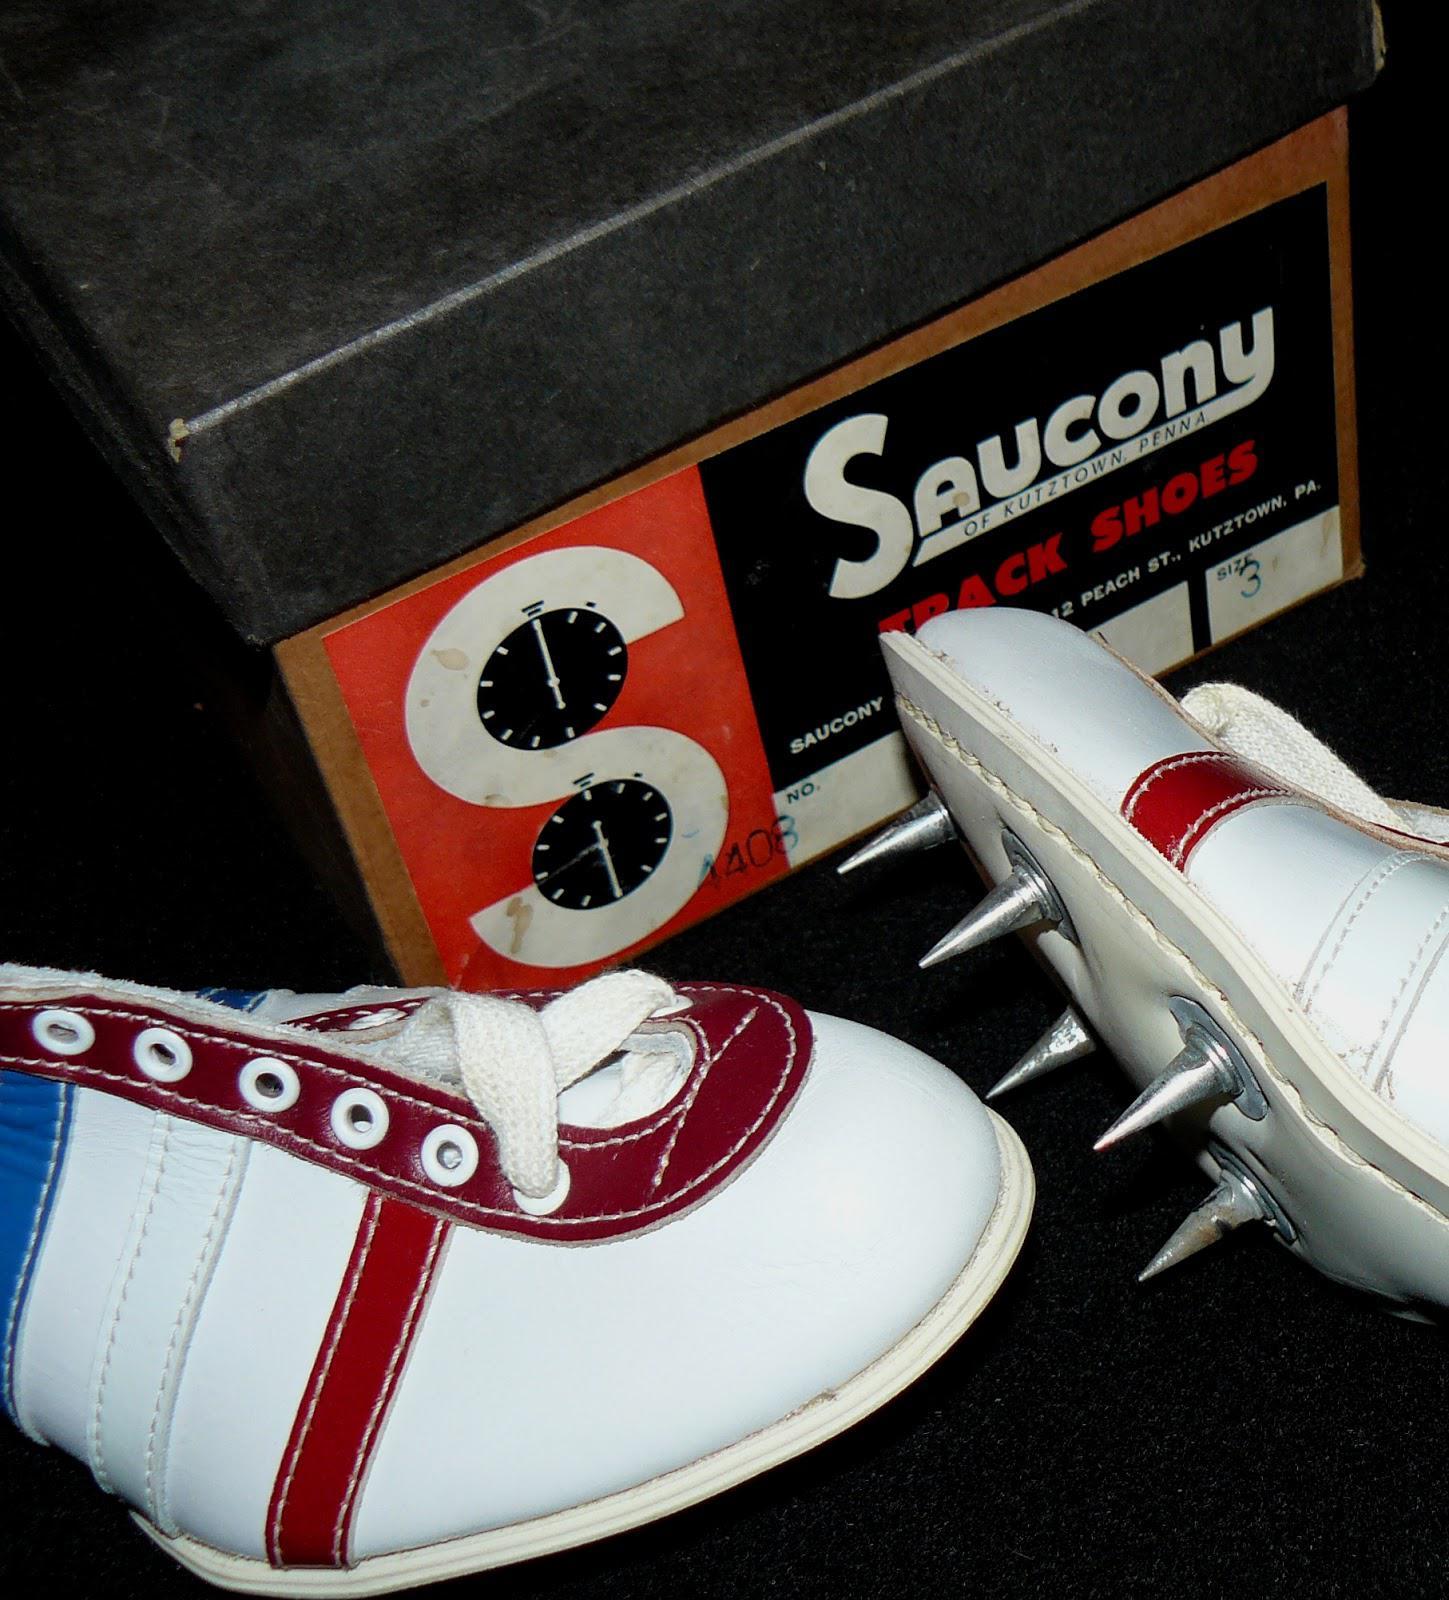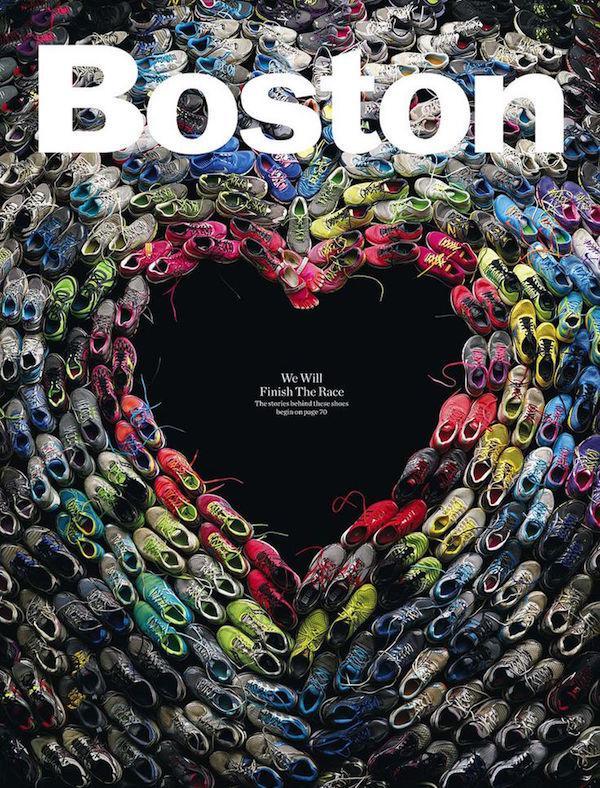The first image is the image on the left, the second image is the image on the right. Evaluate the accuracy of this statement regarding the images: "There are at least 8 shoes.". Is it true? Answer yes or no. Yes. The first image is the image on the left, the second image is the image on the right. For the images displayed, is the sentence "There are many shoes in the image to the right." factually correct? Answer yes or no. Yes. 